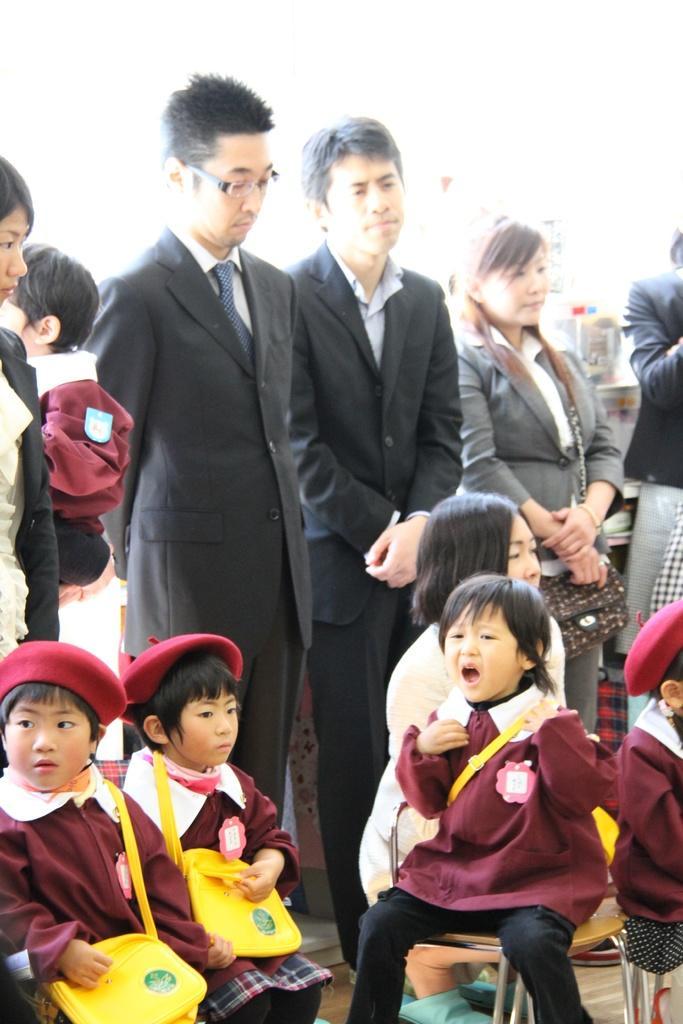Could you give a brief overview of what you see in this image? In this image there are two women standing, there is a woman wearing a bag, there are children sitting towards the bottom of the image, there is a chair towards the bottom of the image, there is a woman carrying a boy, the childrens are wearing bags, they are wearing caps, the background of the image is white. 